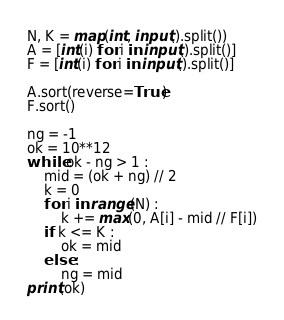<code> <loc_0><loc_0><loc_500><loc_500><_Python_>N, K = map(int, input().split())
A = [int(i) for i in input().split()]
F = [int(i) for i in input().split()]

A.sort(reverse=True)
F.sort()

ng = -1
ok = 10**12
while ok - ng > 1 :
    mid = (ok + ng) // 2
    k = 0
    for i in range(N) :
        k += max(0, A[i] - mid // F[i])
    if k <= K :
        ok = mid
    else :
        ng = mid
print(ok)</code> 